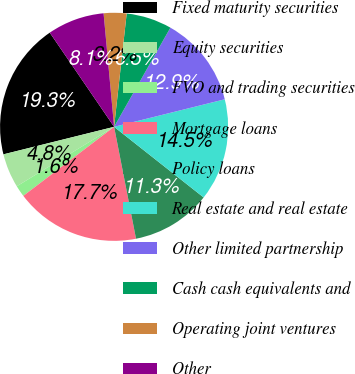Convert chart. <chart><loc_0><loc_0><loc_500><loc_500><pie_chart><fcel>Fixed maturity securities<fcel>Equity securities<fcel>FVO and trading securities<fcel>Mortgage loans<fcel>Policy loans<fcel>Real estate and real estate<fcel>Other limited partnership<fcel>Cash cash equivalents and<fcel>Operating joint ventures<fcel>Other<nl><fcel>19.34%<fcel>4.85%<fcel>1.62%<fcel>17.73%<fcel>11.29%<fcel>14.51%<fcel>12.9%<fcel>6.46%<fcel>3.23%<fcel>8.07%<nl></chart> 